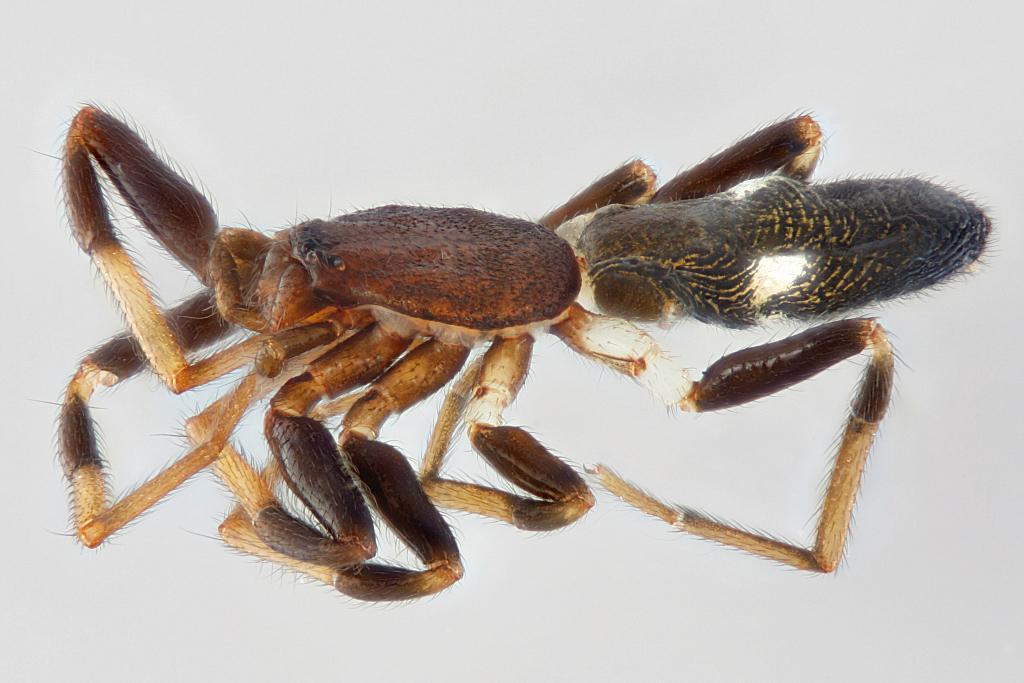Could you give a brief overview of what you see in this image? In this image I can see an insect in brown, black and cream color. Background is in white color. 